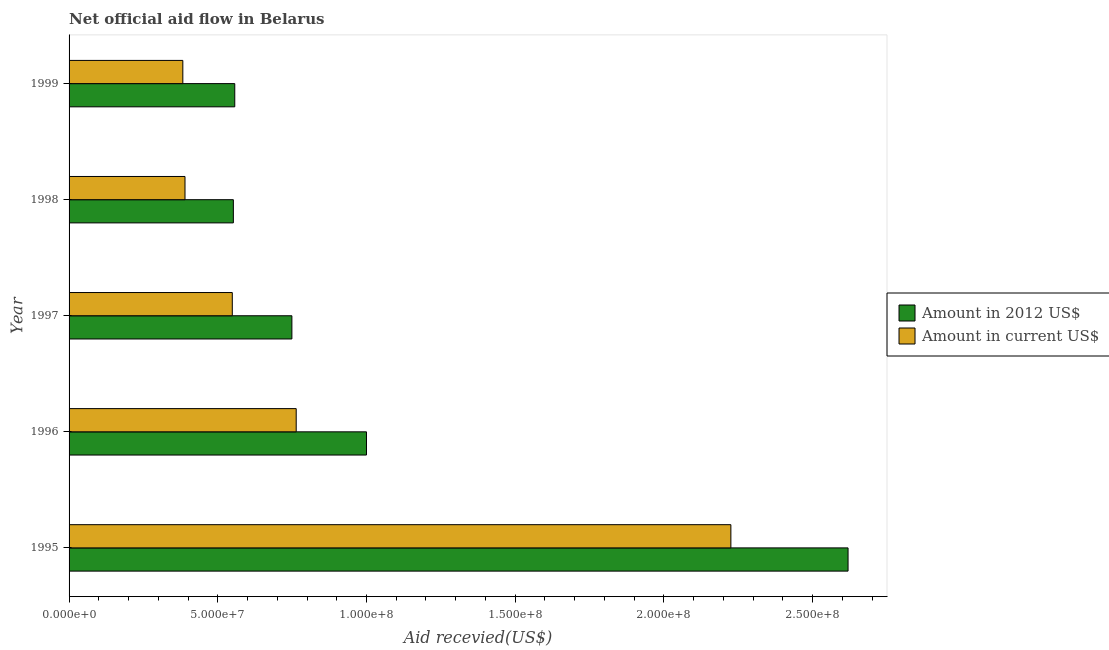Are the number of bars per tick equal to the number of legend labels?
Your answer should be very brief. Yes. Are the number of bars on each tick of the Y-axis equal?
Your response must be concise. Yes. How many bars are there on the 4th tick from the bottom?
Offer a very short reply. 2. What is the amount of aid received(expressed in 2012 us$) in 1998?
Your answer should be very brief. 5.52e+07. Across all years, what is the maximum amount of aid received(expressed in 2012 us$)?
Give a very brief answer. 2.62e+08. Across all years, what is the minimum amount of aid received(expressed in us$)?
Offer a terse response. 3.82e+07. In which year was the amount of aid received(expressed in us$) minimum?
Your answer should be very brief. 1999. What is the total amount of aid received(expressed in 2012 us$) in the graph?
Ensure brevity in your answer.  5.48e+08. What is the difference between the amount of aid received(expressed in us$) in 1996 and that in 1999?
Make the answer very short. 3.81e+07. What is the difference between the amount of aid received(expressed in us$) in 1998 and the amount of aid received(expressed in 2012 us$) in 1997?
Keep it short and to the point. -3.59e+07. What is the average amount of aid received(expressed in 2012 us$) per year?
Offer a terse response. 1.10e+08. In the year 1998, what is the difference between the amount of aid received(expressed in us$) and amount of aid received(expressed in 2012 us$)?
Your response must be concise. -1.63e+07. What is the ratio of the amount of aid received(expressed in 2012 us$) in 1996 to that in 1998?
Offer a terse response. 1.81. Is the amount of aid received(expressed in 2012 us$) in 1998 less than that in 1999?
Your answer should be very brief. Yes. Is the difference between the amount of aid received(expressed in 2012 us$) in 1997 and 1999 greater than the difference between the amount of aid received(expressed in us$) in 1997 and 1999?
Provide a short and direct response. Yes. What is the difference between the highest and the second highest amount of aid received(expressed in 2012 us$)?
Make the answer very short. 1.62e+08. What is the difference between the highest and the lowest amount of aid received(expressed in us$)?
Give a very brief answer. 1.84e+08. In how many years, is the amount of aid received(expressed in us$) greater than the average amount of aid received(expressed in us$) taken over all years?
Provide a succinct answer. 1. Is the sum of the amount of aid received(expressed in us$) in 1995 and 1997 greater than the maximum amount of aid received(expressed in 2012 us$) across all years?
Your answer should be compact. Yes. What does the 2nd bar from the top in 1995 represents?
Offer a terse response. Amount in 2012 US$. What does the 1st bar from the bottom in 1996 represents?
Offer a very short reply. Amount in 2012 US$. Are all the bars in the graph horizontal?
Provide a short and direct response. Yes. How many years are there in the graph?
Provide a succinct answer. 5. Does the graph contain any zero values?
Provide a short and direct response. No. Where does the legend appear in the graph?
Offer a terse response. Center right. How are the legend labels stacked?
Your answer should be very brief. Vertical. What is the title of the graph?
Provide a succinct answer. Net official aid flow in Belarus. Does "IMF nonconcessional" appear as one of the legend labels in the graph?
Your response must be concise. No. What is the label or title of the X-axis?
Offer a terse response. Aid recevied(US$). What is the label or title of the Y-axis?
Your answer should be compact. Year. What is the Aid recevied(US$) of Amount in 2012 US$ in 1995?
Give a very brief answer. 2.62e+08. What is the Aid recevied(US$) in Amount in current US$ in 1995?
Your response must be concise. 2.23e+08. What is the Aid recevied(US$) in Amount in current US$ in 1996?
Keep it short and to the point. 7.64e+07. What is the Aid recevied(US$) of Amount in 2012 US$ in 1997?
Provide a succinct answer. 7.49e+07. What is the Aid recevied(US$) of Amount in current US$ in 1997?
Offer a very short reply. 5.49e+07. What is the Aid recevied(US$) in Amount in 2012 US$ in 1998?
Offer a terse response. 5.52e+07. What is the Aid recevied(US$) of Amount in current US$ in 1998?
Your answer should be very brief. 3.90e+07. What is the Aid recevied(US$) in Amount in 2012 US$ in 1999?
Your answer should be very brief. 5.57e+07. What is the Aid recevied(US$) in Amount in current US$ in 1999?
Your answer should be compact. 3.82e+07. Across all years, what is the maximum Aid recevied(US$) of Amount in 2012 US$?
Your answer should be very brief. 2.62e+08. Across all years, what is the maximum Aid recevied(US$) in Amount in current US$?
Ensure brevity in your answer.  2.23e+08. Across all years, what is the minimum Aid recevied(US$) of Amount in 2012 US$?
Offer a very short reply. 5.52e+07. Across all years, what is the minimum Aid recevied(US$) in Amount in current US$?
Make the answer very short. 3.82e+07. What is the total Aid recevied(US$) in Amount in 2012 US$ in the graph?
Offer a terse response. 5.48e+08. What is the total Aid recevied(US$) in Amount in current US$ in the graph?
Provide a short and direct response. 4.31e+08. What is the difference between the Aid recevied(US$) of Amount in 2012 US$ in 1995 and that in 1996?
Offer a very short reply. 1.62e+08. What is the difference between the Aid recevied(US$) of Amount in current US$ in 1995 and that in 1996?
Ensure brevity in your answer.  1.46e+08. What is the difference between the Aid recevied(US$) in Amount in 2012 US$ in 1995 and that in 1997?
Your answer should be compact. 1.87e+08. What is the difference between the Aid recevied(US$) of Amount in current US$ in 1995 and that in 1997?
Keep it short and to the point. 1.68e+08. What is the difference between the Aid recevied(US$) of Amount in 2012 US$ in 1995 and that in 1998?
Your answer should be compact. 2.07e+08. What is the difference between the Aid recevied(US$) of Amount in current US$ in 1995 and that in 1998?
Offer a very short reply. 1.84e+08. What is the difference between the Aid recevied(US$) in Amount in 2012 US$ in 1995 and that in 1999?
Keep it short and to the point. 2.06e+08. What is the difference between the Aid recevied(US$) of Amount in current US$ in 1995 and that in 1999?
Make the answer very short. 1.84e+08. What is the difference between the Aid recevied(US$) of Amount in 2012 US$ in 1996 and that in 1997?
Keep it short and to the point. 2.51e+07. What is the difference between the Aid recevied(US$) of Amount in current US$ in 1996 and that in 1997?
Your response must be concise. 2.15e+07. What is the difference between the Aid recevied(US$) of Amount in 2012 US$ in 1996 and that in 1998?
Your response must be concise. 4.48e+07. What is the difference between the Aid recevied(US$) in Amount in current US$ in 1996 and that in 1998?
Ensure brevity in your answer.  3.74e+07. What is the difference between the Aid recevied(US$) of Amount in 2012 US$ in 1996 and that in 1999?
Give a very brief answer. 4.43e+07. What is the difference between the Aid recevied(US$) in Amount in current US$ in 1996 and that in 1999?
Your answer should be compact. 3.81e+07. What is the difference between the Aid recevied(US$) of Amount in 2012 US$ in 1997 and that in 1998?
Provide a succinct answer. 1.97e+07. What is the difference between the Aid recevied(US$) in Amount in current US$ in 1997 and that in 1998?
Offer a terse response. 1.59e+07. What is the difference between the Aid recevied(US$) in Amount in 2012 US$ in 1997 and that in 1999?
Your answer should be very brief. 1.92e+07. What is the difference between the Aid recevied(US$) of Amount in current US$ in 1997 and that in 1999?
Offer a very short reply. 1.66e+07. What is the difference between the Aid recevied(US$) in Amount in 2012 US$ in 1998 and that in 1999?
Your response must be concise. -4.70e+05. What is the difference between the Aid recevied(US$) of Amount in current US$ in 1998 and that in 1999?
Your answer should be compact. 7.30e+05. What is the difference between the Aid recevied(US$) of Amount in 2012 US$ in 1995 and the Aid recevied(US$) of Amount in current US$ in 1996?
Offer a terse response. 1.86e+08. What is the difference between the Aid recevied(US$) of Amount in 2012 US$ in 1995 and the Aid recevied(US$) of Amount in current US$ in 1997?
Keep it short and to the point. 2.07e+08. What is the difference between the Aid recevied(US$) in Amount in 2012 US$ in 1995 and the Aid recevied(US$) in Amount in current US$ in 1998?
Provide a short and direct response. 2.23e+08. What is the difference between the Aid recevied(US$) of Amount in 2012 US$ in 1995 and the Aid recevied(US$) of Amount in current US$ in 1999?
Your response must be concise. 2.24e+08. What is the difference between the Aid recevied(US$) in Amount in 2012 US$ in 1996 and the Aid recevied(US$) in Amount in current US$ in 1997?
Offer a terse response. 4.51e+07. What is the difference between the Aid recevied(US$) of Amount in 2012 US$ in 1996 and the Aid recevied(US$) of Amount in current US$ in 1998?
Your answer should be very brief. 6.10e+07. What is the difference between the Aid recevied(US$) in Amount in 2012 US$ in 1996 and the Aid recevied(US$) in Amount in current US$ in 1999?
Provide a short and direct response. 6.18e+07. What is the difference between the Aid recevied(US$) of Amount in 2012 US$ in 1997 and the Aid recevied(US$) of Amount in current US$ in 1998?
Your response must be concise. 3.59e+07. What is the difference between the Aid recevied(US$) of Amount in 2012 US$ in 1997 and the Aid recevied(US$) of Amount in current US$ in 1999?
Make the answer very short. 3.67e+07. What is the difference between the Aid recevied(US$) of Amount in 2012 US$ in 1998 and the Aid recevied(US$) of Amount in current US$ in 1999?
Give a very brief answer. 1.70e+07. What is the average Aid recevied(US$) in Amount in 2012 US$ per year?
Your response must be concise. 1.10e+08. What is the average Aid recevied(US$) in Amount in current US$ per year?
Offer a terse response. 8.62e+07. In the year 1995, what is the difference between the Aid recevied(US$) of Amount in 2012 US$ and Aid recevied(US$) of Amount in current US$?
Your answer should be compact. 3.94e+07. In the year 1996, what is the difference between the Aid recevied(US$) in Amount in 2012 US$ and Aid recevied(US$) in Amount in current US$?
Give a very brief answer. 2.36e+07. In the year 1997, what is the difference between the Aid recevied(US$) in Amount in 2012 US$ and Aid recevied(US$) in Amount in current US$?
Give a very brief answer. 2.00e+07. In the year 1998, what is the difference between the Aid recevied(US$) in Amount in 2012 US$ and Aid recevied(US$) in Amount in current US$?
Your answer should be very brief. 1.63e+07. In the year 1999, what is the difference between the Aid recevied(US$) in Amount in 2012 US$ and Aid recevied(US$) in Amount in current US$?
Keep it short and to the point. 1.75e+07. What is the ratio of the Aid recevied(US$) of Amount in 2012 US$ in 1995 to that in 1996?
Your answer should be compact. 2.62. What is the ratio of the Aid recevied(US$) of Amount in current US$ in 1995 to that in 1996?
Keep it short and to the point. 2.91. What is the ratio of the Aid recevied(US$) of Amount in 2012 US$ in 1995 to that in 1997?
Your answer should be very brief. 3.5. What is the ratio of the Aid recevied(US$) of Amount in current US$ in 1995 to that in 1997?
Offer a very short reply. 4.05. What is the ratio of the Aid recevied(US$) of Amount in 2012 US$ in 1995 to that in 1998?
Your response must be concise. 4.74. What is the ratio of the Aid recevied(US$) of Amount in current US$ in 1995 to that in 1998?
Your response must be concise. 5.71. What is the ratio of the Aid recevied(US$) in Amount in 2012 US$ in 1995 to that in 1999?
Provide a succinct answer. 4.7. What is the ratio of the Aid recevied(US$) of Amount in current US$ in 1995 to that in 1999?
Your response must be concise. 5.82. What is the ratio of the Aid recevied(US$) of Amount in 2012 US$ in 1996 to that in 1997?
Give a very brief answer. 1.33. What is the ratio of the Aid recevied(US$) of Amount in current US$ in 1996 to that in 1997?
Offer a very short reply. 1.39. What is the ratio of the Aid recevied(US$) in Amount in 2012 US$ in 1996 to that in 1998?
Give a very brief answer. 1.81. What is the ratio of the Aid recevied(US$) of Amount in current US$ in 1996 to that in 1998?
Ensure brevity in your answer.  1.96. What is the ratio of the Aid recevied(US$) of Amount in 2012 US$ in 1996 to that in 1999?
Ensure brevity in your answer.  1.79. What is the ratio of the Aid recevied(US$) of Amount in current US$ in 1996 to that in 1999?
Your answer should be very brief. 2. What is the ratio of the Aid recevied(US$) of Amount in 2012 US$ in 1997 to that in 1998?
Provide a succinct answer. 1.36. What is the ratio of the Aid recevied(US$) of Amount in current US$ in 1997 to that in 1998?
Ensure brevity in your answer.  1.41. What is the ratio of the Aid recevied(US$) in Amount in 2012 US$ in 1997 to that in 1999?
Provide a succinct answer. 1.34. What is the ratio of the Aid recevied(US$) in Amount in current US$ in 1997 to that in 1999?
Give a very brief answer. 1.43. What is the ratio of the Aid recevied(US$) of Amount in 2012 US$ in 1998 to that in 1999?
Provide a short and direct response. 0.99. What is the ratio of the Aid recevied(US$) of Amount in current US$ in 1998 to that in 1999?
Provide a succinct answer. 1.02. What is the difference between the highest and the second highest Aid recevied(US$) of Amount in 2012 US$?
Your answer should be very brief. 1.62e+08. What is the difference between the highest and the second highest Aid recevied(US$) of Amount in current US$?
Keep it short and to the point. 1.46e+08. What is the difference between the highest and the lowest Aid recevied(US$) in Amount in 2012 US$?
Your answer should be very brief. 2.07e+08. What is the difference between the highest and the lowest Aid recevied(US$) of Amount in current US$?
Keep it short and to the point. 1.84e+08. 